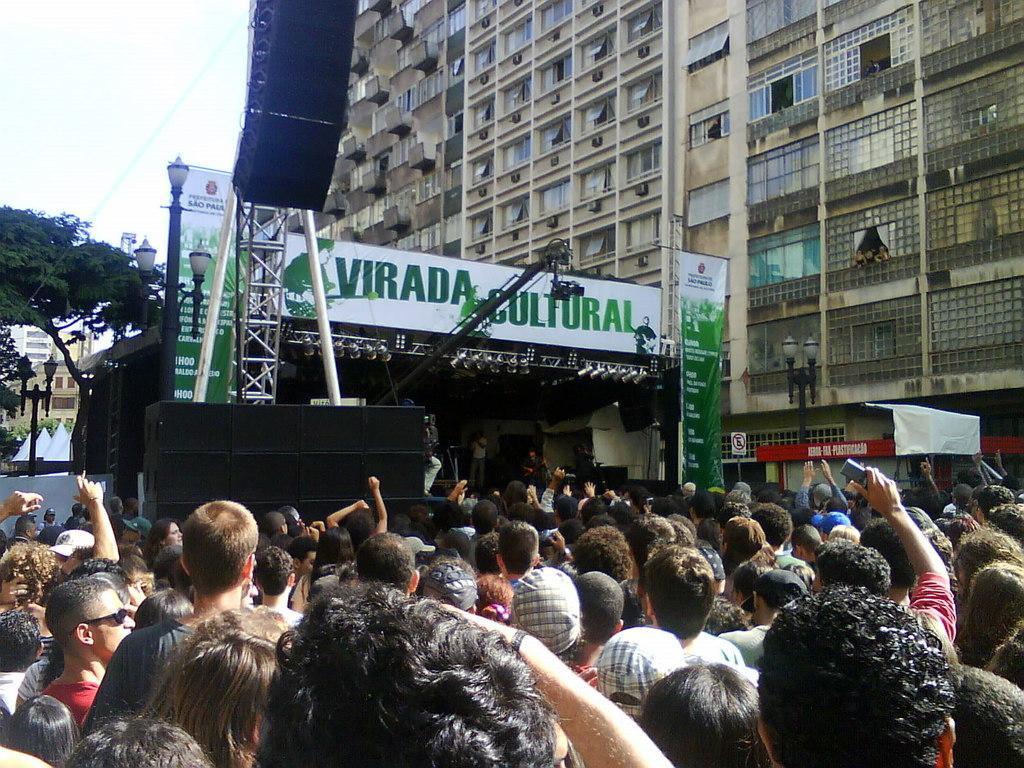How would you summarize this image in a sentence or two? At the bottom of the image, we can see the crowd. On the right side of the image, we can see a person holding an object. In the background, there are few speakers, people, rods, banners, street lights, trees, buildings, railings, windows, walls, sign board, few objects and the sky. 